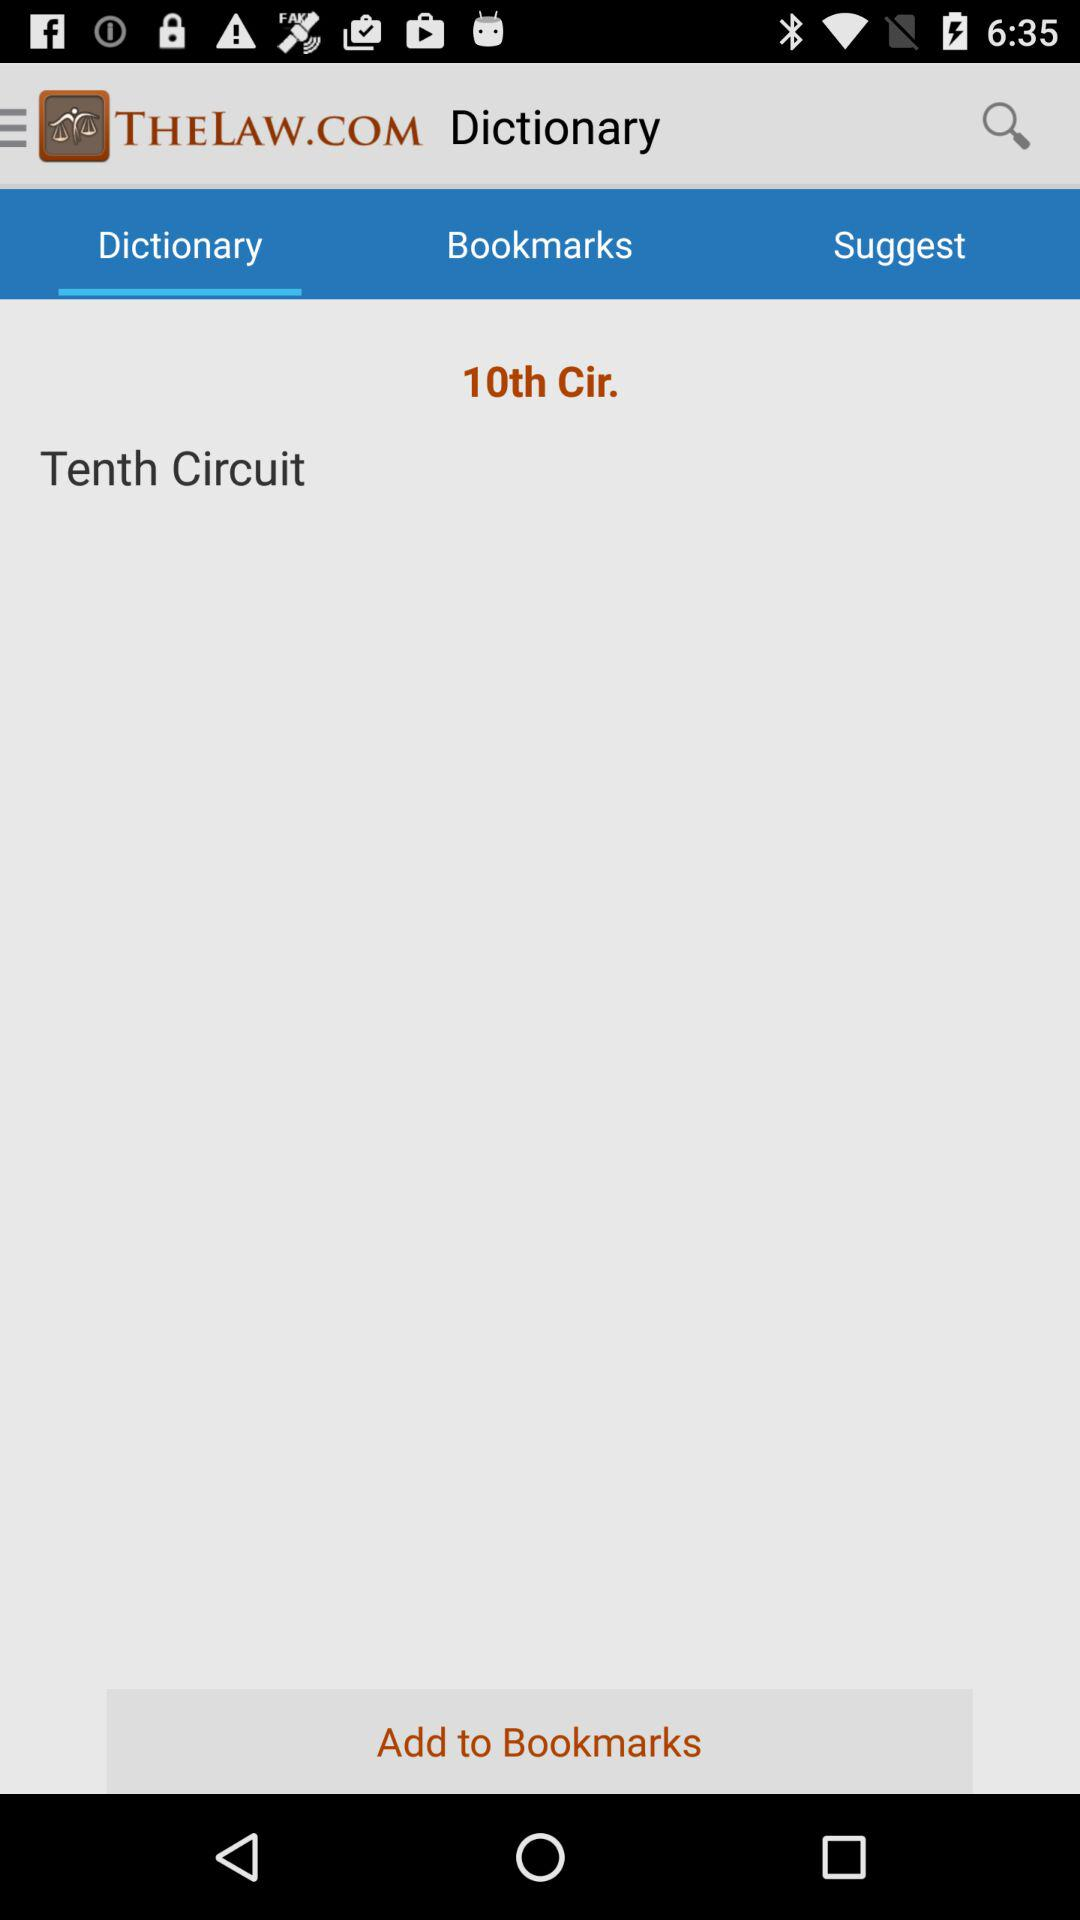Which option is selected? The selected option is "Dictionary". 